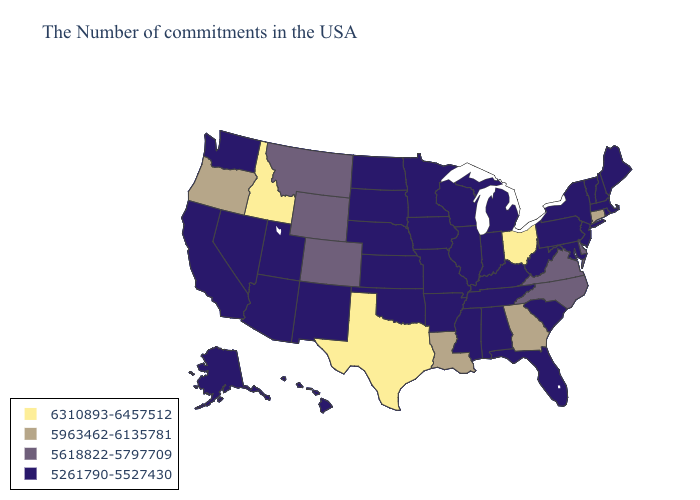What is the highest value in the Northeast ?
Answer briefly. 5963462-6135781. Among the states that border Washington , which have the lowest value?
Concise answer only. Oregon. Does Vermont have the highest value in the USA?
Be succinct. No. Which states have the lowest value in the South?
Keep it brief. Maryland, South Carolina, West Virginia, Florida, Kentucky, Alabama, Tennessee, Mississippi, Arkansas, Oklahoma. Which states have the lowest value in the USA?
Short answer required. Maine, Massachusetts, Rhode Island, New Hampshire, Vermont, New York, New Jersey, Maryland, Pennsylvania, South Carolina, West Virginia, Florida, Michigan, Kentucky, Indiana, Alabama, Tennessee, Wisconsin, Illinois, Mississippi, Missouri, Arkansas, Minnesota, Iowa, Kansas, Nebraska, Oklahoma, South Dakota, North Dakota, New Mexico, Utah, Arizona, Nevada, California, Washington, Alaska, Hawaii. What is the lowest value in states that border Florida?
Short answer required. 5261790-5527430. What is the lowest value in the Northeast?
Give a very brief answer. 5261790-5527430. What is the value of Montana?
Concise answer only. 5618822-5797709. What is the highest value in the Northeast ?
Write a very short answer. 5963462-6135781. Which states have the lowest value in the USA?
Write a very short answer. Maine, Massachusetts, Rhode Island, New Hampshire, Vermont, New York, New Jersey, Maryland, Pennsylvania, South Carolina, West Virginia, Florida, Michigan, Kentucky, Indiana, Alabama, Tennessee, Wisconsin, Illinois, Mississippi, Missouri, Arkansas, Minnesota, Iowa, Kansas, Nebraska, Oklahoma, South Dakota, North Dakota, New Mexico, Utah, Arizona, Nevada, California, Washington, Alaska, Hawaii. What is the value of Utah?
Be succinct. 5261790-5527430. Name the states that have a value in the range 6310893-6457512?
Keep it brief. Ohio, Texas, Idaho. Name the states that have a value in the range 5261790-5527430?
Be succinct. Maine, Massachusetts, Rhode Island, New Hampshire, Vermont, New York, New Jersey, Maryland, Pennsylvania, South Carolina, West Virginia, Florida, Michigan, Kentucky, Indiana, Alabama, Tennessee, Wisconsin, Illinois, Mississippi, Missouri, Arkansas, Minnesota, Iowa, Kansas, Nebraska, Oklahoma, South Dakota, North Dakota, New Mexico, Utah, Arizona, Nevada, California, Washington, Alaska, Hawaii. Name the states that have a value in the range 6310893-6457512?
Keep it brief. Ohio, Texas, Idaho. Does Arkansas have a lower value than Virginia?
Quick response, please. Yes. 